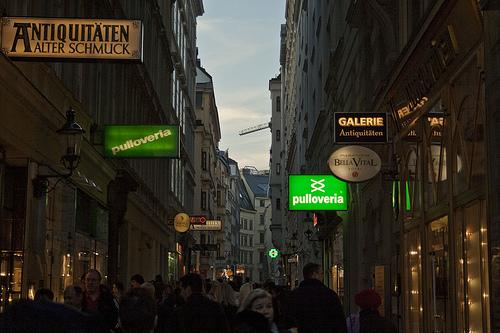Analyze the interaction between the people and the environment in the image. People appear to be walking or engaging with each other, possibly browsing or shopping near the store signs. How many store signs can be identified in the image, and what is the general color scheme? There are at least 7 store signs. They mostly have a green, white, or black color scheme. What color and text is included in the sign associated with the galerie? The sign is black with white letters and reads "galerie antiquitaten." Quantify the number of individuals present on the street. The image shows a crowd of people, but the exact number of individuals is unclear. Explain whether the atmosphere in the image is busy or calm. The atmosphere is busy, with people walking on a narrow street and multiple lit store signs. Briefly describe the appearance of the person with a red hat. A woman wearing a deep red hat on her head, possibly engaged in the crowd. Identify the primary focus of the image and its action. A group of people walking down the street in front of tall buildings with lit up store signs. Assess the quality of the image in terms of clarity and details. The image quality seems decent, with visible details like store signs, people, and architecture. Evaluate the overall sentiment or mood conveyed by the image. The image conveys a bustling and lively mood, with people in interaction and lit up store signs. Mention a unique feature about the street lamps in the image. There is an ornate black light fixture on one of the street lamps. What color is the hat worn by a woman in the image? Red Describe the lighting condition in the image. The sunlight is fading, and store signs are illuminated. Is there a sign that says "alter schmuck" with white writing on a black background? The sign that says "alter schmuck" has black writing on a white background, not the other way around. Are there signboards with black writing on them observable in the image? If so, name one. Yes, a sign that reads "Antiquitaten Alter Schmuck" has black writing on it. What does the lit up sign above the store say? Galerie Antiquitaten Describe the objects and activity happening in the image. People are walking down a narrow street with tall buildings lined up, lit-up store signs, and a crowd near the buildings. Choose the correct phrase for the lit up store sign: a) Galerie Antiques, b) Galerie Antiquitaten, c) Galerie Artifacts. b) Galerie Antiquitaten Is the crowd of people near or far from the tall buildings? Near Is there an ornate black light fixture present in the image? Yes Which signs are illuminated in the image? Galerie, Pulloveria, Antiquitaten, and Bellavital signs Is the woman wearing a blue hat? The woman is wearing a red hat, not a blue one. Can you see a person with a full head of hair standing next to the bald guy? There is no mention of a person with a full head of hair standing next to the bald guy, so the instruction is misleading. Name a feature of the man's physical appearance. He is bald. What type of store signs can you see in the image? Antiquitaten, Pulloveria, Bella Vital, and Galerie What type of items can you see in the lit up window display? Cannot accurately determine from the information given. Identify the actions of the people in the image. The crowd of people is walking down the street and a woman wearing a red hat. Can you find a yellow sign that reads "pulloveria"? The sign that reads "pulloveria" is green and white, not yellow. Are the buildings in the image tall or short? Tall What type of road can be seen in the image? A narrow, parked street Identify the colors of the brand logos you can see in the image. White and red Describe the position of the buildings in the image. The tall buildings are side by side and in front of the people. What color are the lights on the building? Green There is a store sign that reads "Pulloveria". Describe the sign's color. Green and white Are the green lights shining close by? The green lights are described as shining in the distance, not close by. Do the buildings have no windows? The buildings have windows, so the question is misleading. 